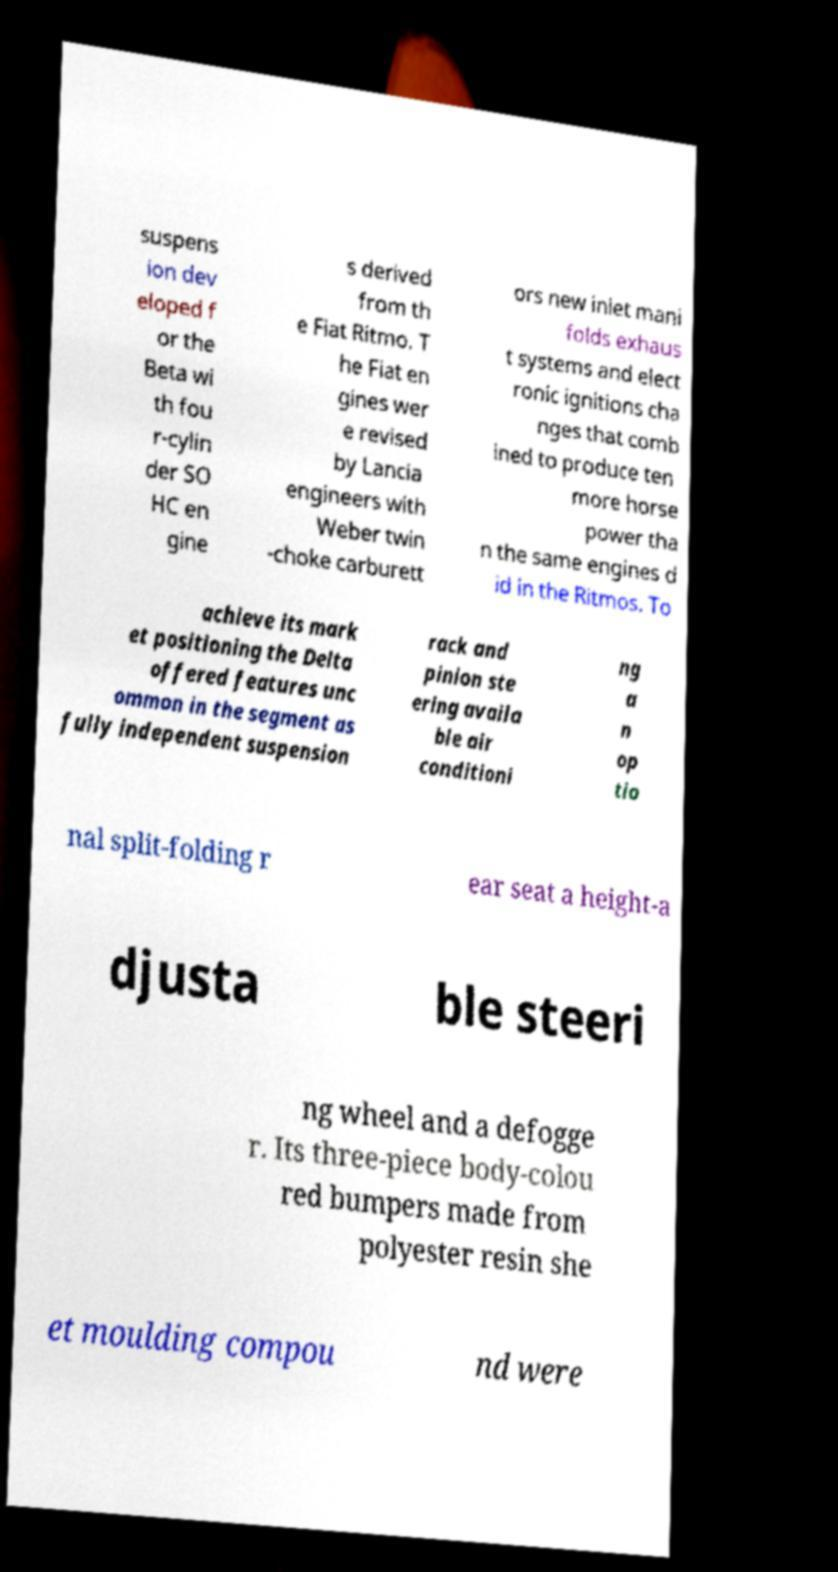Please read and relay the text visible in this image. What does it say? suspens ion dev eloped f or the Beta wi th fou r-cylin der SO HC en gine s derived from th e Fiat Ritmo. T he Fiat en gines wer e revised by Lancia engineers with Weber twin -choke carburett ors new inlet mani folds exhaus t systems and elect ronic ignitions cha nges that comb ined to produce ten more horse power tha n the same engines d id in the Ritmos. To achieve its mark et positioning the Delta offered features unc ommon in the segment as fully independent suspension rack and pinion ste ering availa ble air conditioni ng a n op tio nal split-folding r ear seat a height-a djusta ble steeri ng wheel and a defogge r. Its three-piece body-colou red bumpers made from polyester resin she et moulding compou nd were 